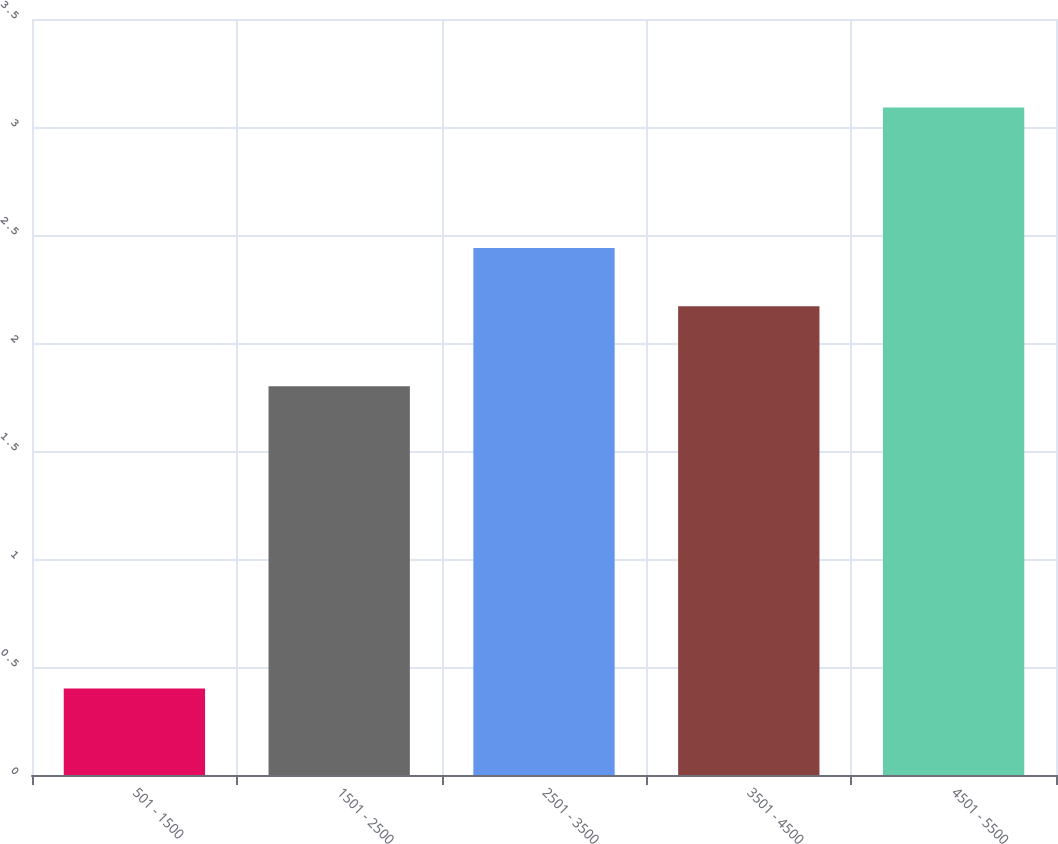Convert chart. <chart><loc_0><loc_0><loc_500><loc_500><bar_chart><fcel>501 - 1500<fcel>1501 - 2500<fcel>2501 - 3500<fcel>3501 - 4500<fcel>4501 - 5500<nl><fcel>0.4<fcel>1.8<fcel>2.44<fcel>2.17<fcel>3.09<nl></chart> 